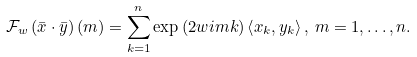Convert formula to latex. <formula><loc_0><loc_0><loc_500><loc_500>\mathcal { F } _ { w } \left ( \bar { x } \cdot \bar { y } \right ) \left ( m \right ) = \sum _ { k = 1 } ^ { n } \exp \left ( 2 w i m k \right ) \left \langle x _ { k } , y _ { k } \right \rangle , \, m = 1 , \dots , n .</formula> 